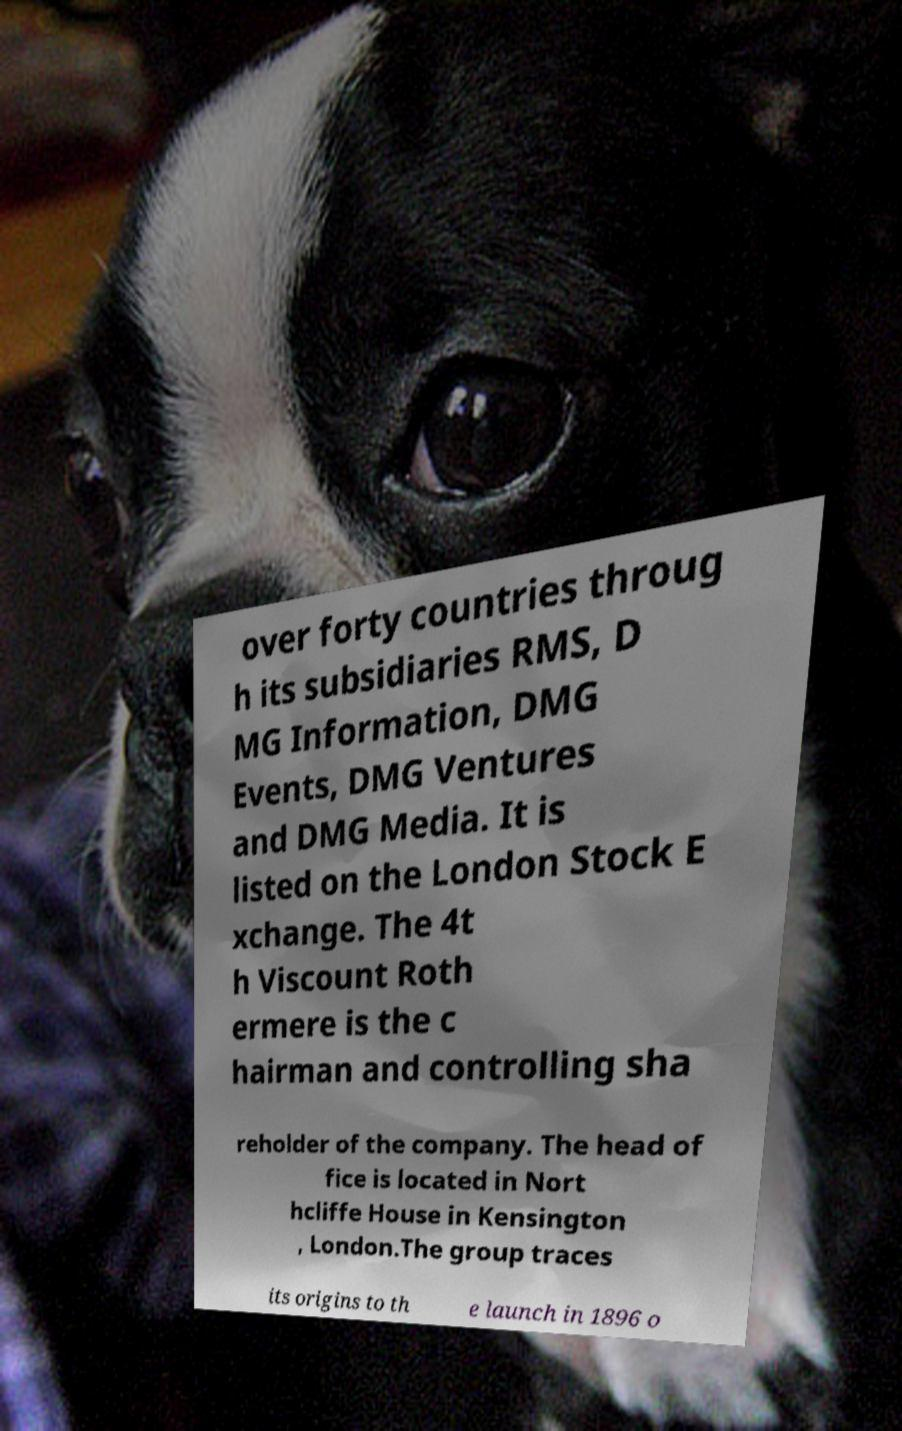I need the written content from this picture converted into text. Can you do that? over forty countries throug h its subsidiaries RMS, D MG Information, DMG Events, DMG Ventures and DMG Media. It is listed on the London Stock E xchange. The 4t h Viscount Roth ermere is the c hairman and controlling sha reholder of the company. The head of fice is located in Nort hcliffe House in Kensington , London.The group traces its origins to th e launch in 1896 o 